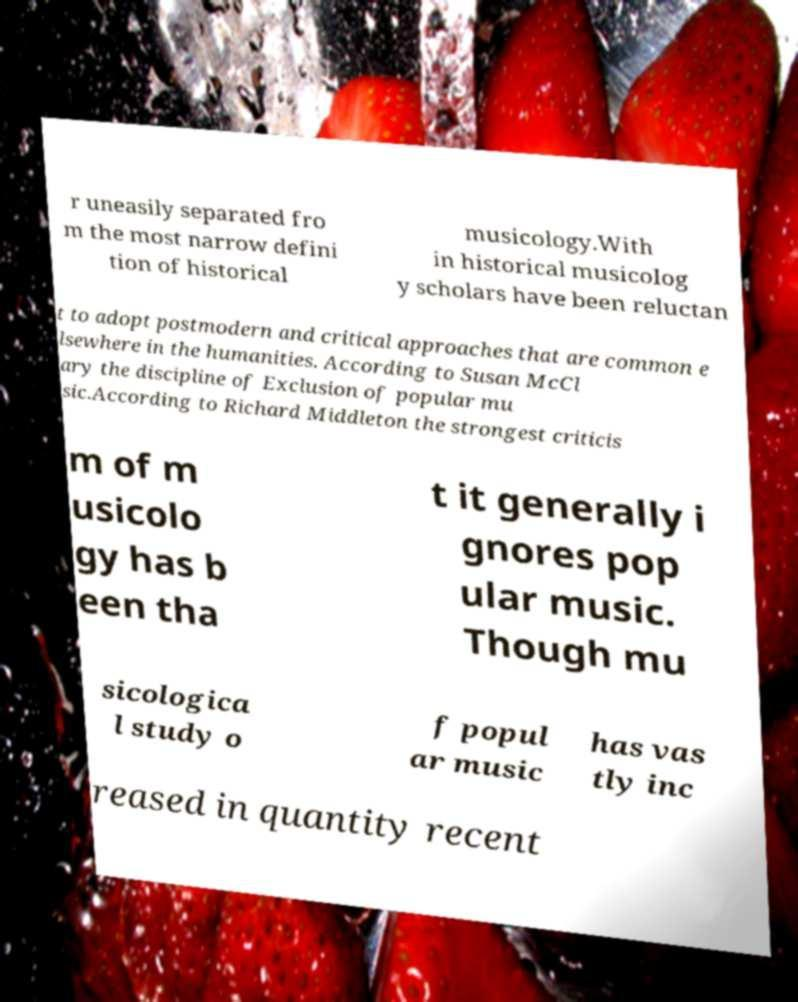Can you accurately transcribe the text from the provided image for me? r uneasily separated fro m the most narrow defini tion of historical musicology.With in historical musicolog y scholars have been reluctan t to adopt postmodern and critical approaches that are common e lsewhere in the humanities. According to Susan McCl ary the discipline of Exclusion of popular mu sic.According to Richard Middleton the strongest criticis m of m usicolo gy has b een tha t it generally i gnores pop ular music. Though mu sicologica l study o f popul ar music has vas tly inc reased in quantity recent 